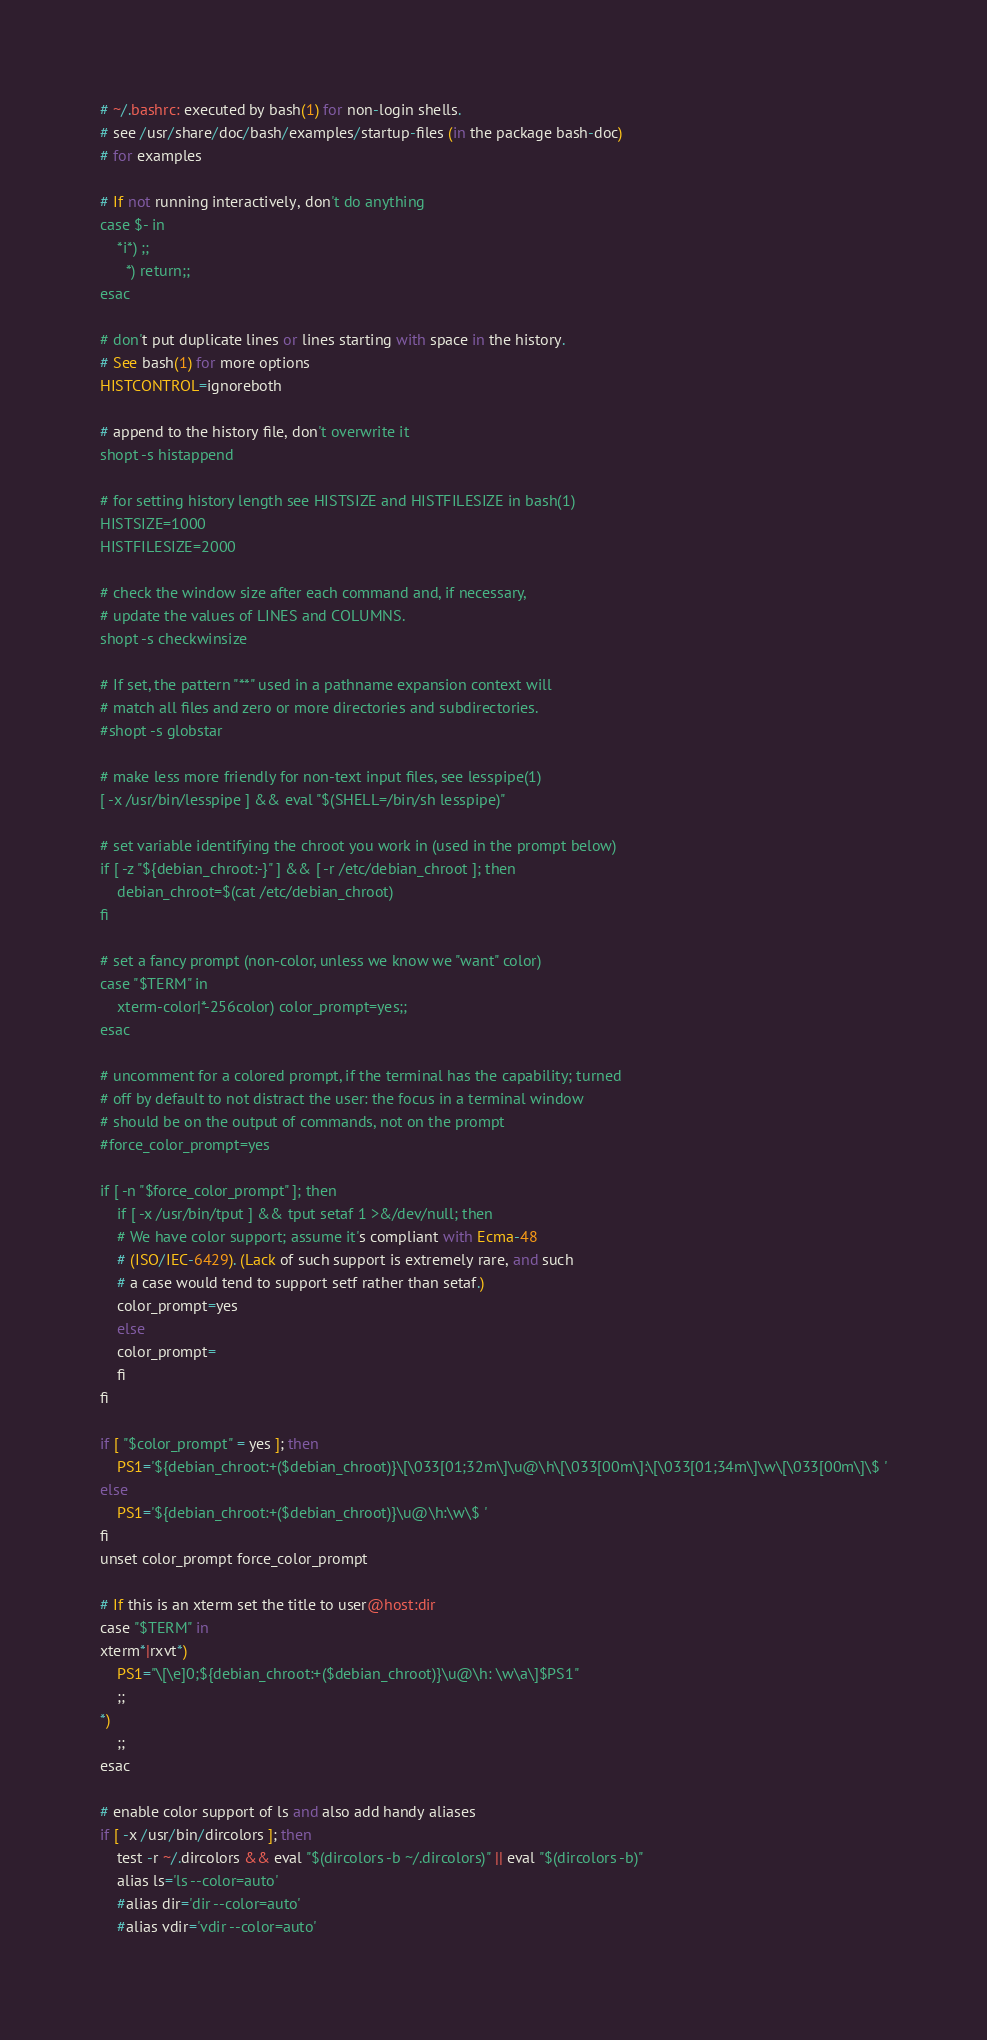<code> <loc_0><loc_0><loc_500><loc_500><_MoonScript_># ~/.bashrc: executed by bash(1) for non-login shells.
# see /usr/share/doc/bash/examples/startup-files (in the package bash-doc)
# for examples

# If not running interactively, don't do anything
case $- in
    *i*) ;;
      *) return;;
esac

# don't put duplicate lines or lines starting with space in the history.
# See bash(1) for more options
HISTCONTROL=ignoreboth

# append to the history file, don't overwrite it
shopt -s histappend

# for setting history length see HISTSIZE and HISTFILESIZE in bash(1)
HISTSIZE=1000
HISTFILESIZE=2000

# check the window size after each command and, if necessary,
# update the values of LINES and COLUMNS.
shopt -s checkwinsize

# If set, the pattern "**" used in a pathname expansion context will
# match all files and zero or more directories and subdirectories.
#shopt -s globstar

# make less more friendly for non-text input files, see lesspipe(1)
[ -x /usr/bin/lesspipe ] && eval "$(SHELL=/bin/sh lesspipe)"

# set variable identifying the chroot you work in (used in the prompt below)
if [ -z "${debian_chroot:-}" ] && [ -r /etc/debian_chroot ]; then
    debian_chroot=$(cat /etc/debian_chroot)
fi

# set a fancy prompt (non-color, unless we know we "want" color)
case "$TERM" in
    xterm-color|*-256color) color_prompt=yes;;
esac

# uncomment for a colored prompt, if the terminal has the capability; turned
# off by default to not distract the user: the focus in a terminal window
# should be on the output of commands, not on the prompt
#force_color_prompt=yes

if [ -n "$force_color_prompt" ]; then
    if [ -x /usr/bin/tput ] && tput setaf 1 >&/dev/null; then
	# We have color support; assume it's compliant with Ecma-48
	# (ISO/IEC-6429). (Lack of such support is extremely rare, and such
	# a case would tend to support setf rather than setaf.)
	color_prompt=yes
    else
	color_prompt=
    fi
fi

if [ "$color_prompt" = yes ]; then
    PS1='${debian_chroot:+($debian_chroot)}\[\033[01;32m\]\u@\h\[\033[00m\]:\[\033[01;34m\]\w\[\033[00m\]\$ '
else
    PS1='${debian_chroot:+($debian_chroot)}\u@\h:\w\$ '
fi
unset color_prompt force_color_prompt

# If this is an xterm set the title to user@host:dir
case "$TERM" in
xterm*|rxvt*)
    PS1="\[\e]0;${debian_chroot:+($debian_chroot)}\u@\h: \w\a\]$PS1"
    ;;
*)
    ;;
esac

# enable color support of ls and also add handy aliases
if [ -x /usr/bin/dircolors ]; then
    test -r ~/.dircolors && eval "$(dircolors -b ~/.dircolors)" || eval "$(dircolors -b)"
    alias ls='ls --color=auto'
    #alias dir='dir --color=auto'
    #alias vdir='vdir --color=auto'
</code> 